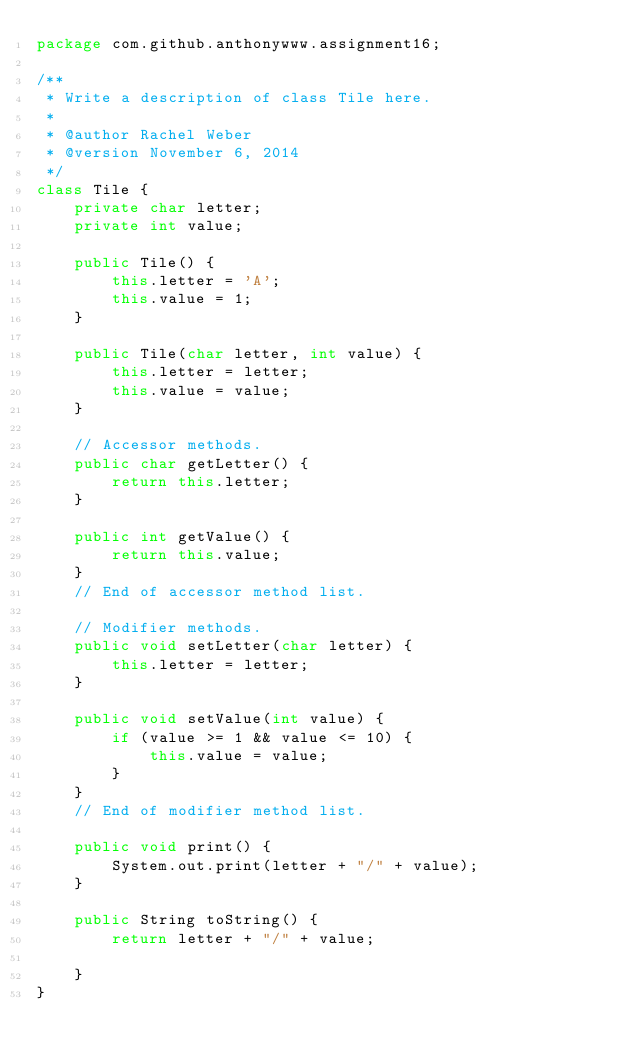Convert code to text. <code><loc_0><loc_0><loc_500><loc_500><_Java_>package com.github.anthonywww.assignment16;

/**
 * Write a description of class Tile here.
 * 
 * @author Rachel Weber
 * @version November 6, 2014
 */
class Tile {
	private char letter;
	private int value;

	public Tile() {
		this.letter = 'A';
		this.value = 1;
	}

	public Tile(char letter, int value) {
		this.letter = letter;
		this.value = value;
	}

	// Accessor methods.
	public char getLetter() {
		return this.letter;
	}

	public int getValue() {
		return this.value;
	}
	// End of accessor method list.

	// Modifier methods.
	public void setLetter(char letter) {
		this.letter = letter;
	}

	public void setValue(int value) {
		if (value >= 1 && value <= 10) {
			this.value = value;
		}
	}
	// End of modifier method list.

	public void print() {
		System.out.print(letter + "/" + value);
	}

	public String toString() {
		return letter + "/" + value;

	}
}
</code> 